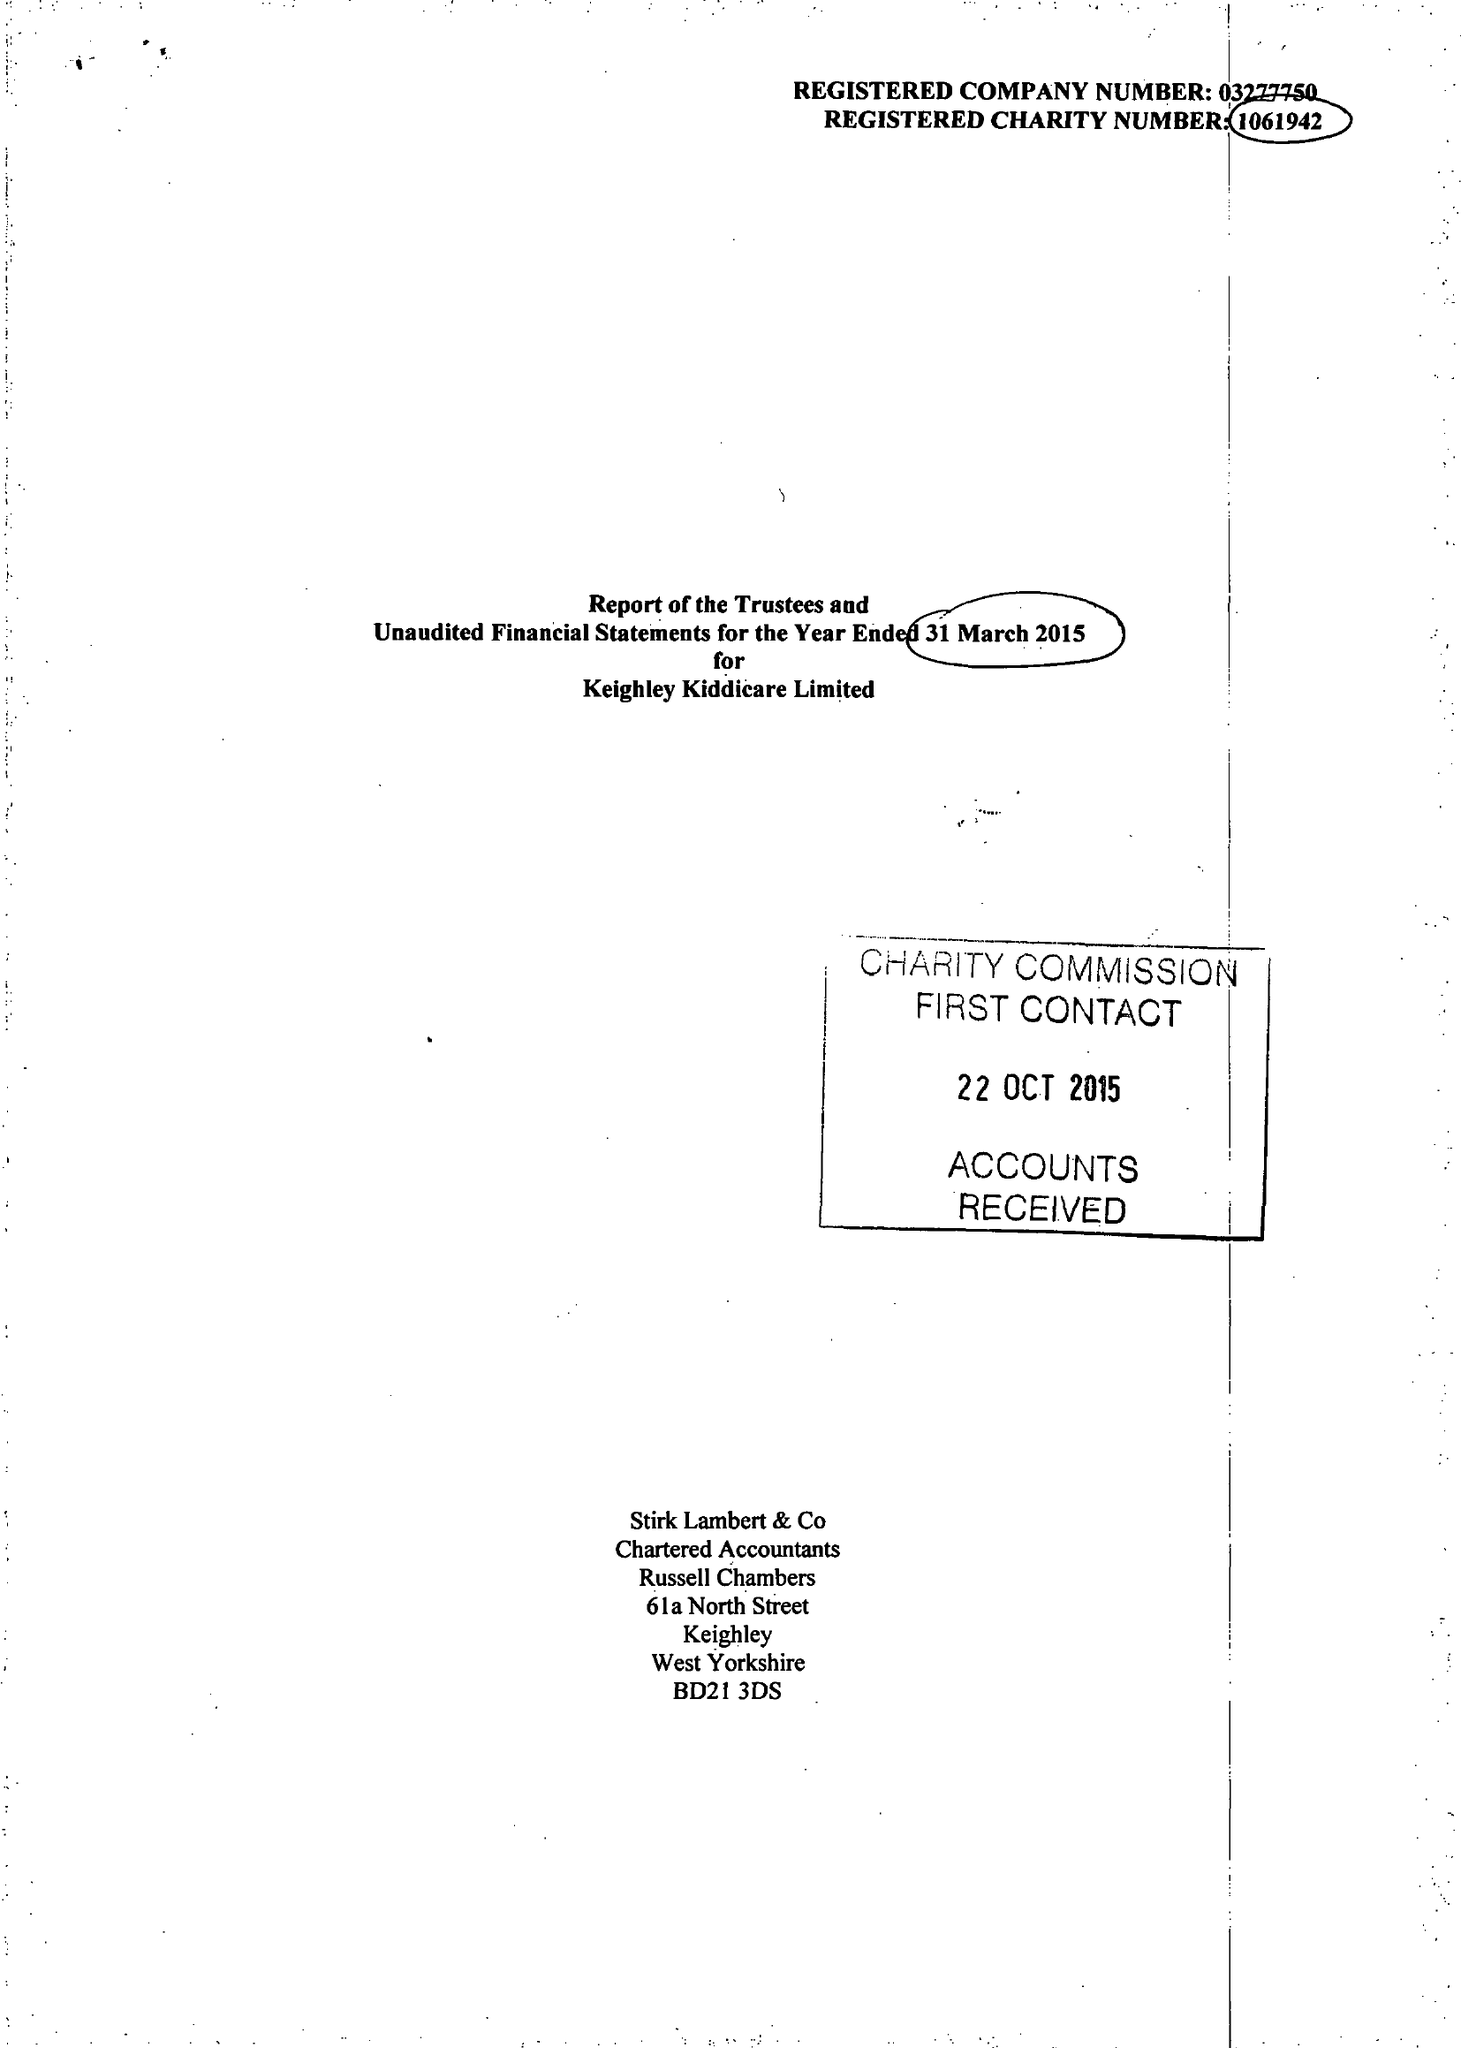What is the value for the spending_annually_in_british_pounds?
Answer the question using a single word or phrase. 488512.00 